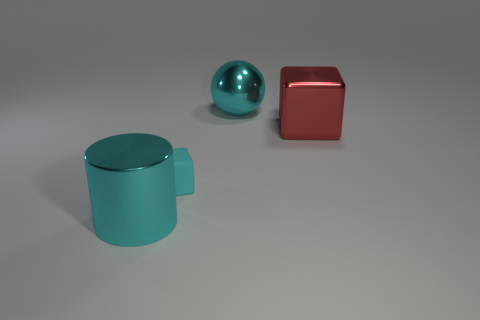Is there any other thing that is the same size as the cyan matte thing?
Your answer should be very brief. No. What is the cyan thing that is in front of the cyan rubber block made of?
Offer a terse response. Metal. The matte block that is the same color as the cylinder is what size?
Your answer should be very brief. Small. There is a block on the left side of the large red shiny block; is it the same color as the large thing to the left of the large sphere?
Ensure brevity in your answer.  Yes. What number of things are big gray cubes or tiny cyan objects?
Provide a succinct answer. 1. What number of other things are the same shape as the large red thing?
Provide a short and direct response. 1. Is the material of the cyan cylinder that is on the left side of the small matte thing the same as the block right of the small rubber object?
Your answer should be compact. Yes. There is a cyan thing that is both on the right side of the large cyan cylinder and in front of the big red block; what is its shape?
Offer a terse response. Cube. Is there anything else that is the same material as the small cyan object?
Your answer should be compact. No. What material is the thing that is both in front of the large cube and behind the big cyan cylinder?
Offer a very short reply. Rubber. 